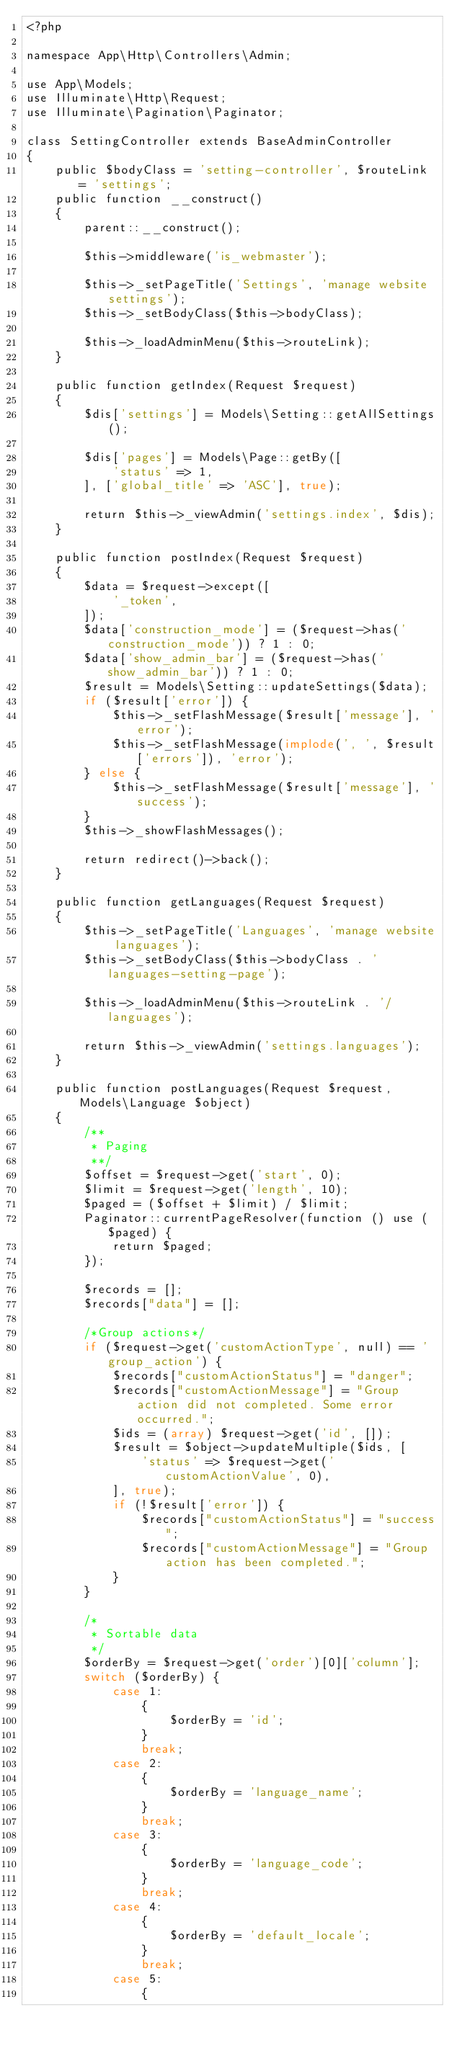<code> <loc_0><loc_0><loc_500><loc_500><_PHP_><?php

namespace App\Http\Controllers\Admin;

use App\Models;
use Illuminate\Http\Request;
use Illuminate\Pagination\Paginator;

class SettingController extends BaseAdminController
{
    public $bodyClass = 'setting-controller', $routeLink = 'settings';
    public function __construct()
    {
        parent::__construct();

        $this->middleware('is_webmaster');

        $this->_setPageTitle('Settings', 'manage website settings');
        $this->_setBodyClass($this->bodyClass);

        $this->_loadAdminMenu($this->routeLink);
    }

    public function getIndex(Request $request)
    {
        $dis['settings'] = Models\Setting::getAllSettings();

        $dis['pages'] = Models\Page::getBy([
            'status' => 1,
        ], ['global_title' => 'ASC'], true);

        return $this->_viewAdmin('settings.index', $dis);
    }

    public function postIndex(Request $request)
    {
        $data = $request->except([
            '_token',
        ]);
        $data['construction_mode'] = ($request->has('construction_mode')) ? 1 : 0;
        $data['show_admin_bar'] = ($request->has('show_admin_bar')) ? 1 : 0;
        $result = Models\Setting::updateSettings($data);
        if ($result['error']) {
            $this->_setFlashMessage($result['message'], 'error');
            $this->_setFlashMessage(implode(', ', $result['errors']), 'error');
        } else {
            $this->_setFlashMessage($result['message'], 'success');
        }
        $this->_showFlashMessages();

        return redirect()->back();
    }

    public function getLanguages(Request $request)
    {
        $this->_setPageTitle('Languages', 'manage website languages');
        $this->_setBodyClass($this->bodyClass . ' languages-setting-page');

        $this->_loadAdminMenu($this->routeLink . '/languages');

        return $this->_viewAdmin('settings.languages');
    }

    public function postLanguages(Request $request, Models\Language $object)
    {
        /**
         * Paging
         **/
        $offset = $request->get('start', 0);
        $limit = $request->get('length', 10);
        $paged = ($offset + $limit) / $limit;
        Paginator::currentPageResolver(function () use ($paged) {
            return $paged;
        });

        $records = [];
        $records["data"] = [];

        /*Group actions*/
        if ($request->get('customActionType', null) == 'group_action') {
            $records["customActionStatus"] = "danger";
            $records["customActionMessage"] = "Group action did not completed. Some error occurred.";
            $ids = (array) $request->get('id', []);
            $result = $object->updateMultiple($ids, [
                'status' => $request->get('customActionValue', 0),
            ], true);
            if (!$result['error']) {
                $records["customActionStatus"] = "success";
                $records["customActionMessage"] = "Group action has been completed.";
            }
        }

        /*
         * Sortable data
         */
        $orderBy = $request->get('order')[0]['column'];
        switch ($orderBy) {
            case 1:
                {
                    $orderBy = 'id';
                }
                break;
            case 2:
                {
                    $orderBy = 'language_name';
                }
                break;
            case 3:
                {
                    $orderBy = 'language_code';
                }
                break;
            case 4:
                {
                    $orderBy = 'default_locale';
                }
                break;
            case 5:
                {</code> 